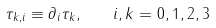Convert formula to latex. <formula><loc_0><loc_0><loc_500><loc_500>\tau _ { k , i } \equiv \partial _ { i } \tau _ { k } , \quad i , k = 0 , 1 , 2 , 3</formula> 